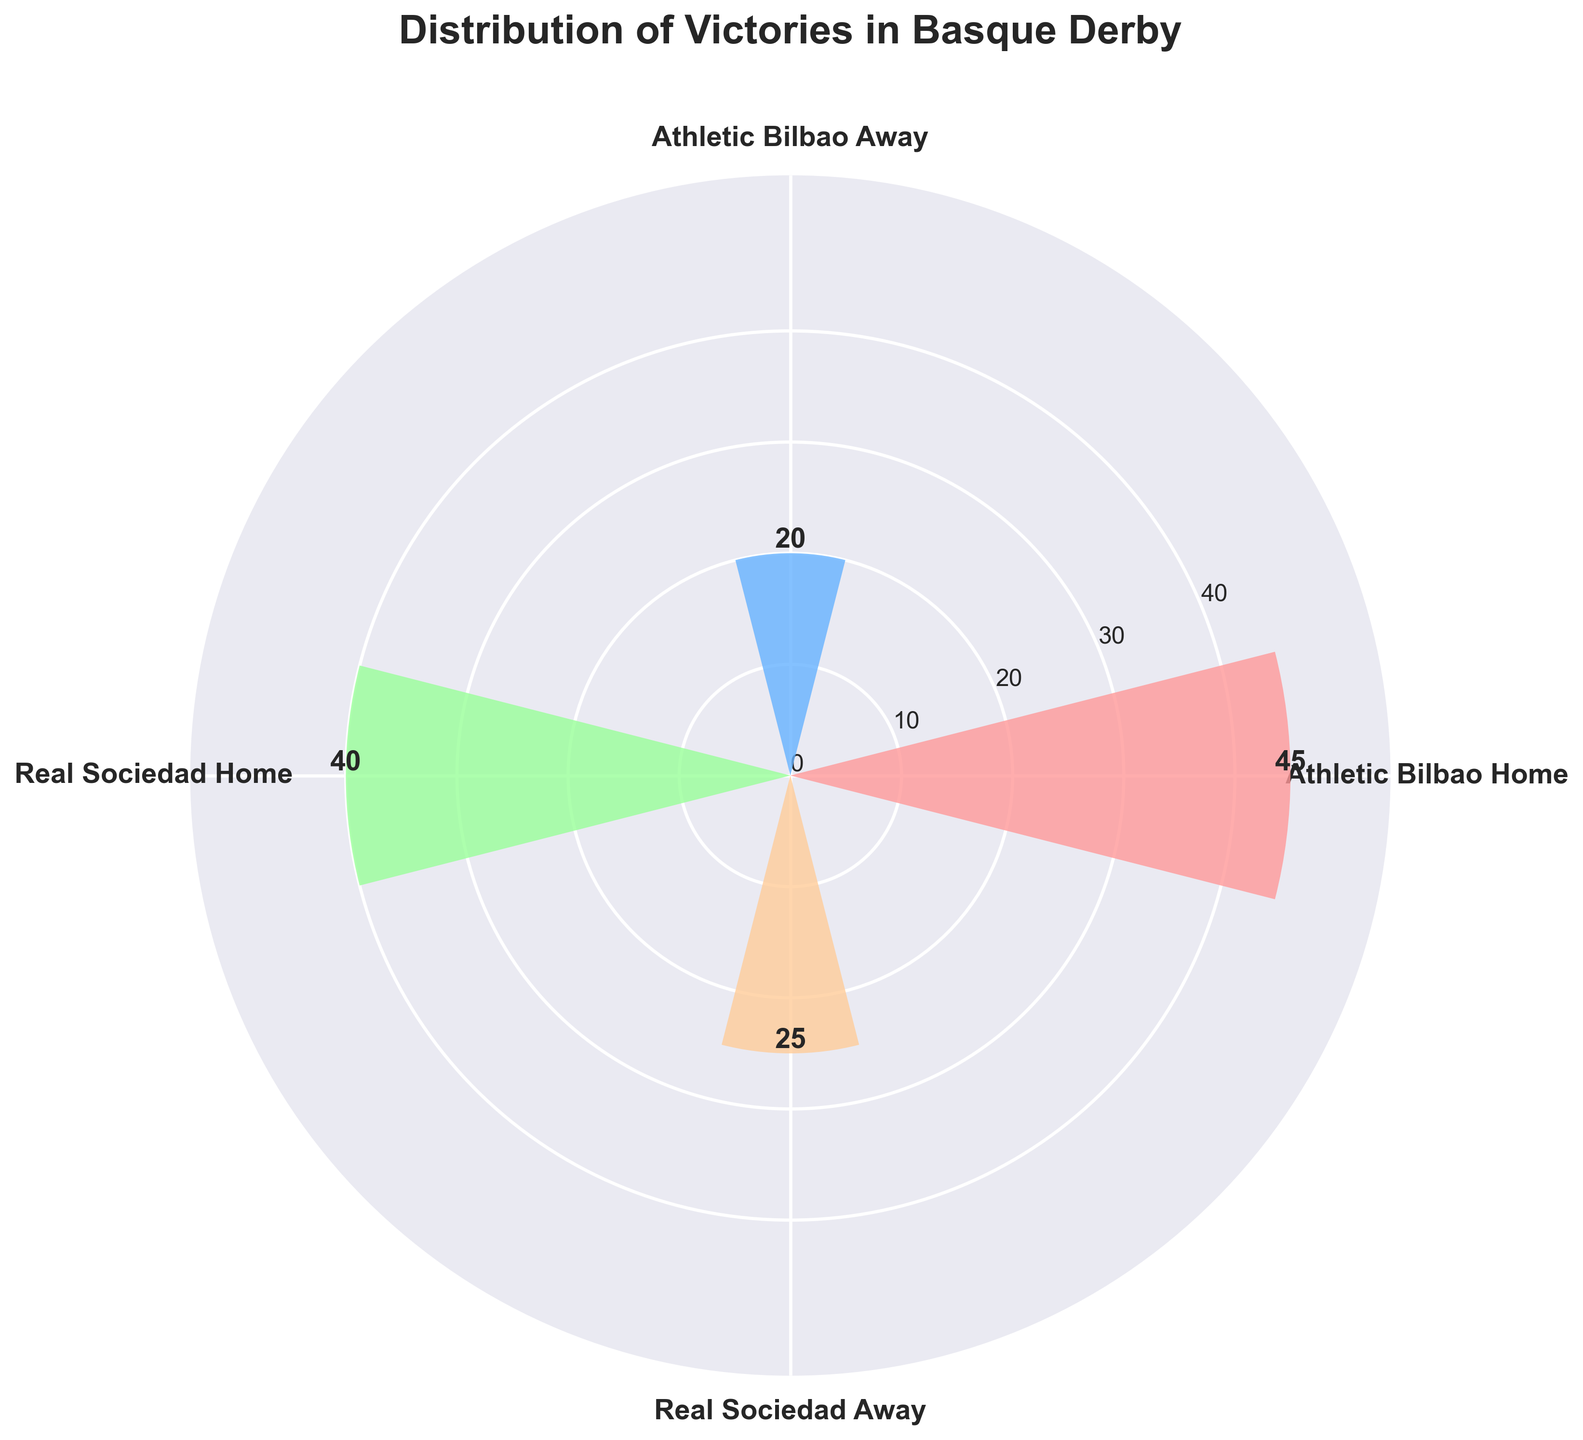What's the title of the figure? The title is usually placed at the top of the figure. In this case, it reads "Distribution of Victories in Basque Derby."
Answer: Distribution of Victories in Basque Derby Which team has more home victories? The team with the highest bar in the home category has more victories. Athletic Bilbao home has 45 victories, whereas Real Sociedad home has 40 victories.
Answer: Athletic Bilbao What is the total number of victories for Real Sociedad? To find the total, sum Real Sociedad's home and away victories: 40 (home) + 25 (away) = 65.
Answer: 65 How many more home victories does Athletic Bilbao have compared to Real Sociedad? Subtract Real Sociedad's home victories from Athletic Bilbao's home victories: 45 - 40 = 5.
Answer: 5 What is the difference between Athletic Bilbao's home and away victories? Subtract away victories from home victories for Athletic Bilbao: 45 - 20 = 25.
Answer: 25 Which category has the fewest victories? The category with the shortest bar represents the fewest victories. Athletic Bilbao away has 20 victories.
Answer: Athletic Bilbao Away How does the number of away victories for both teams compare? Compare the away victories: Athletic Bilbao (20) vs. Real Sociedad (25). Real Sociedad has more away victories.
Answer: Real Sociedad has more What's the combined total of all victories in the Basque derby? Sum all four categories: 45 (Athletic Bilbao Home) + 20 (Athletic Bilbao Away) + 40 (Real Sociedad Home) + 25 (Real Sociedad Away) = 130.
Answer: 130 What percentage of Real Sociedad's total victories are away victories? Calculate Real Sociedad's total victories (65) and determine the percentage of away victories (25): (25 / 65) * 100 ≈ 38.46%.
Answer: ≈ 38.46% Among the four categories, which two have the closest number of victories? Compare pairs: Athletic Bilbao Home (45) & Real Sociedad Home (40); Real Sociedad Home (40) & Real Sociedad Away (25); and Athletic Bilbao Away (20) & Real Sociedad Away (25). The closest pair is Real Sociedad Away and Real Sociedad Home with a difference of 5.
Answer: Real Sociedad Home and Real Sociedad Away 